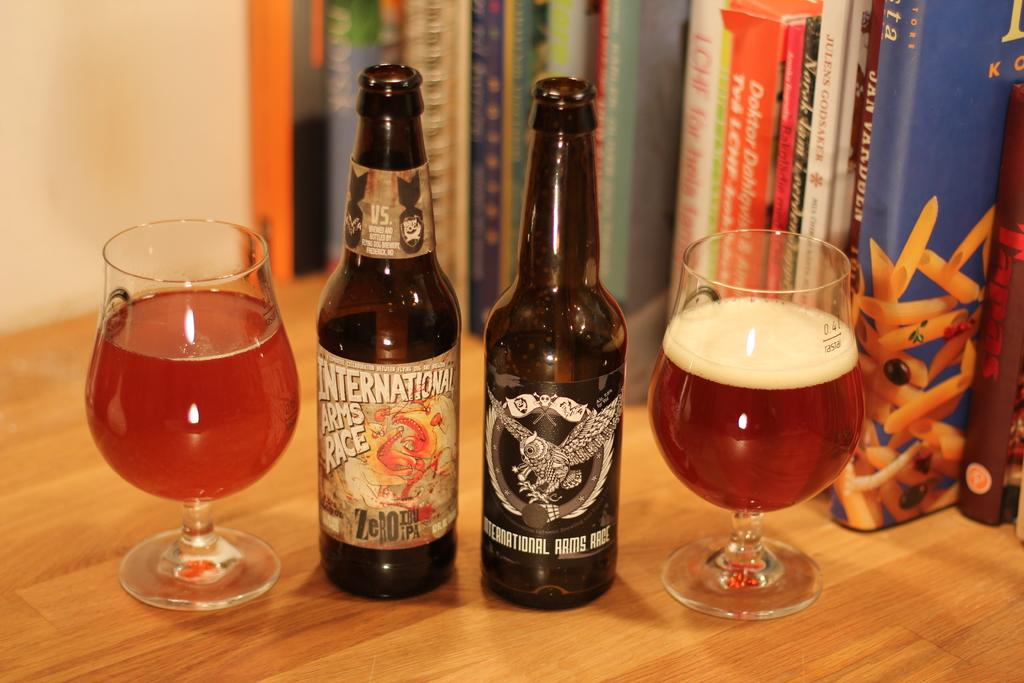<image>
Render a clear and concise summary of the photo. the word international is on the front of a beer bottle 